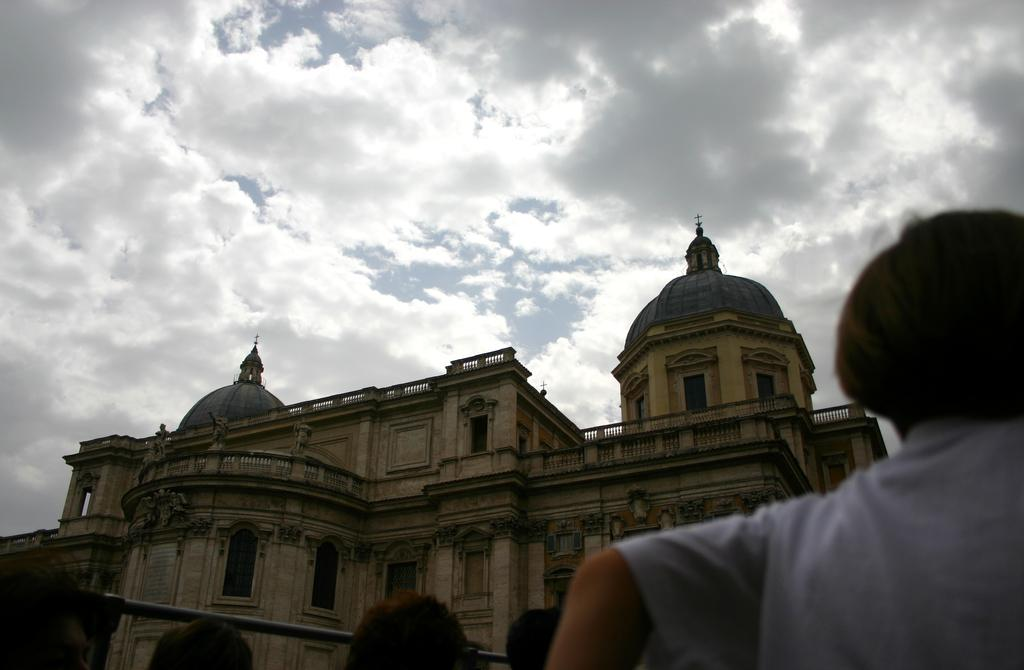What is the main subject in the center of the image? There is a building in the center of the image. What else can be seen at the bottom of the image? There are people at the bottom of the image. What can be seen in the background of the image? The sky is visible in the background of the image. What type of machine is being used by the people at the bottom of the image? There is no machine visible in the image; only the building, people, and sky are present. 